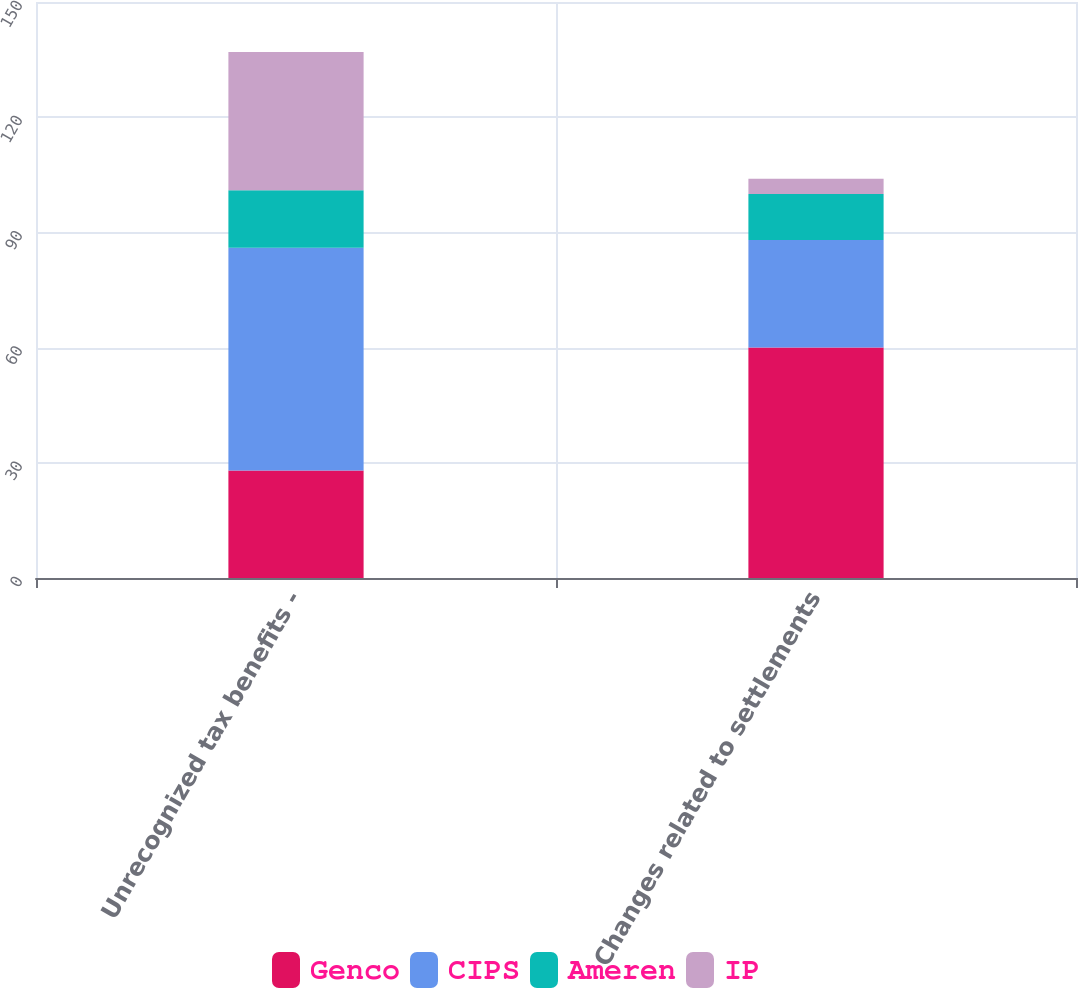Convert chart. <chart><loc_0><loc_0><loc_500><loc_500><stacked_bar_chart><ecel><fcel>Unrecognized tax benefits -<fcel>Changes related to settlements<nl><fcel>Genco<fcel>28<fcel>60<nl><fcel>CIPS<fcel>58<fcel>28<nl><fcel>Ameren<fcel>15<fcel>12<nl><fcel>IP<fcel>36<fcel>4<nl></chart> 